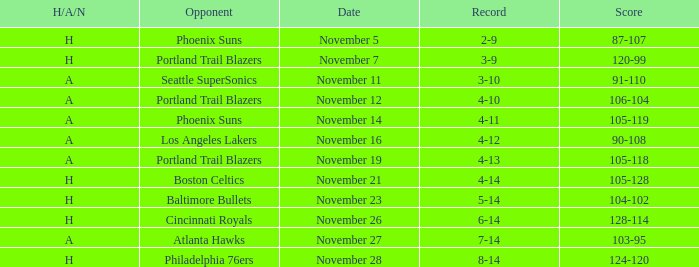On what Date was the Score 106-104 against the Portland Trail Blazers? November 12. 